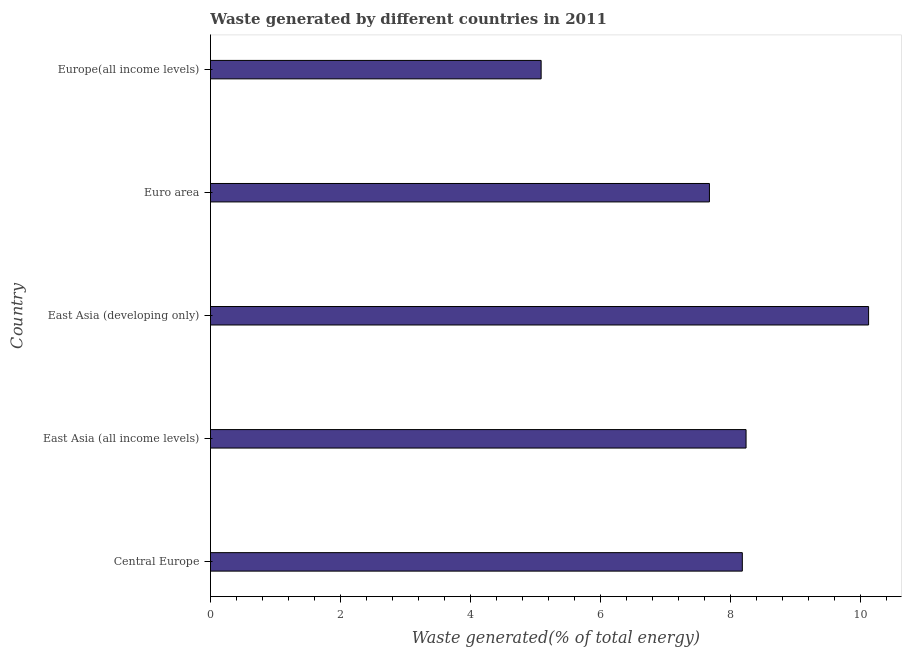What is the title of the graph?
Provide a short and direct response. Waste generated by different countries in 2011. What is the label or title of the X-axis?
Give a very brief answer. Waste generated(% of total energy). What is the label or title of the Y-axis?
Keep it short and to the point. Country. What is the amount of waste generated in East Asia (developing only)?
Provide a short and direct response. 10.12. Across all countries, what is the maximum amount of waste generated?
Provide a short and direct response. 10.12. Across all countries, what is the minimum amount of waste generated?
Provide a short and direct response. 5.09. In which country was the amount of waste generated maximum?
Ensure brevity in your answer.  East Asia (developing only). In which country was the amount of waste generated minimum?
Keep it short and to the point. Europe(all income levels). What is the sum of the amount of waste generated?
Ensure brevity in your answer.  39.29. What is the difference between the amount of waste generated in East Asia (all income levels) and Euro area?
Your answer should be very brief. 0.56. What is the average amount of waste generated per country?
Your answer should be very brief. 7.86. What is the median amount of waste generated?
Provide a succinct answer. 8.18. What is the ratio of the amount of waste generated in Central Europe to that in East Asia (developing only)?
Keep it short and to the point. 0.81. Is the difference between the amount of waste generated in East Asia (all income levels) and Euro area greater than the difference between any two countries?
Your answer should be compact. No. What is the difference between the highest and the second highest amount of waste generated?
Provide a succinct answer. 1.88. Is the sum of the amount of waste generated in Central Europe and Europe(all income levels) greater than the maximum amount of waste generated across all countries?
Provide a succinct answer. Yes. What is the difference between the highest and the lowest amount of waste generated?
Ensure brevity in your answer.  5.04. In how many countries, is the amount of waste generated greater than the average amount of waste generated taken over all countries?
Keep it short and to the point. 3. How many countries are there in the graph?
Provide a short and direct response. 5. What is the difference between two consecutive major ticks on the X-axis?
Provide a succinct answer. 2. Are the values on the major ticks of X-axis written in scientific E-notation?
Keep it short and to the point. No. What is the Waste generated(% of total energy) in Central Europe?
Offer a very short reply. 8.18. What is the Waste generated(% of total energy) of East Asia (all income levels)?
Offer a terse response. 8.24. What is the Waste generated(% of total energy) in East Asia (developing only)?
Keep it short and to the point. 10.12. What is the Waste generated(% of total energy) in Euro area?
Ensure brevity in your answer.  7.67. What is the Waste generated(% of total energy) in Europe(all income levels)?
Your answer should be very brief. 5.09. What is the difference between the Waste generated(% of total energy) in Central Europe and East Asia (all income levels)?
Offer a terse response. -0.06. What is the difference between the Waste generated(% of total energy) in Central Europe and East Asia (developing only)?
Ensure brevity in your answer.  -1.94. What is the difference between the Waste generated(% of total energy) in Central Europe and Euro area?
Give a very brief answer. 0.51. What is the difference between the Waste generated(% of total energy) in Central Europe and Europe(all income levels)?
Make the answer very short. 3.09. What is the difference between the Waste generated(% of total energy) in East Asia (all income levels) and East Asia (developing only)?
Your answer should be compact. -1.88. What is the difference between the Waste generated(% of total energy) in East Asia (all income levels) and Euro area?
Make the answer very short. 0.56. What is the difference between the Waste generated(% of total energy) in East Asia (all income levels) and Europe(all income levels)?
Make the answer very short. 3.15. What is the difference between the Waste generated(% of total energy) in East Asia (developing only) and Euro area?
Your response must be concise. 2.45. What is the difference between the Waste generated(% of total energy) in East Asia (developing only) and Europe(all income levels)?
Your response must be concise. 5.04. What is the difference between the Waste generated(% of total energy) in Euro area and Europe(all income levels)?
Provide a succinct answer. 2.59. What is the ratio of the Waste generated(% of total energy) in Central Europe to that in East Asia (all income levels)?
Keep it short and to the point. 0.99. What is the ratio of the Waste generated(% of total energy) in Central Europe to that in East Asia (developing only)?
Offer a very short reply. 0.81. What is the ratio of the Waste generated(% of total energy) in Central Europe to that in Euro area?
Offer a very short reply. 1.07. What is the ratio of the Waste generated(% of total energy) in Central Europe to that in Europe(all income levels)?
Ensure brevity in your answer.  1.61. What is the ratio of the Waste generated(% of total energy) in East Asia (all income levels) to that in East Asia (developing only)?
Offer a terse response. 0.81. What is the ratio of the Waste generated(% of total energy) in East Asia (all income levels) to that in Euro area?
Provide a short and direct response. 1.07. What is the ratio of the Waste generated(% of total energy) in East Asia (all income levels) to that in Europe(all income levels)?
Provide a succinct answer. 1.62. What is the ratio of the Waste generated(% of total energy) in East Asia (developing only) to that in Euro area?
Keep it short and to the point. 1.32. What is the ratio of the Waste generated(% of total energy) in East Asia (developing only) to that in Europe(all income levels)?
Keep it short and to the point. 1.99. What is the ratio of the Waste generated(% of total energy) in Euro area to that in Europe(all income levels)?
Your answer should be very brief. 1.51. 